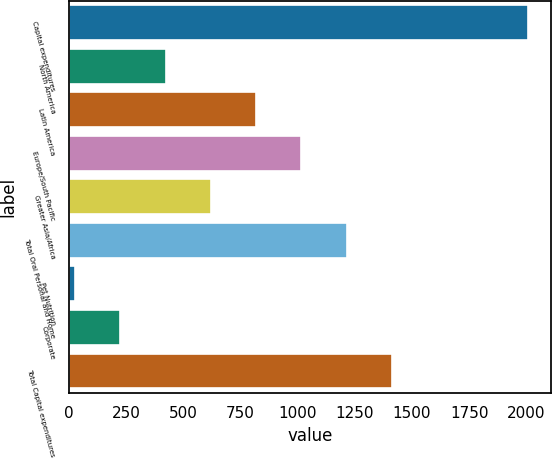Convert chart to OTSL. <chart><loc_0><loc_0><loc_500><loc_500><bar_chart><fcel>Capital expenditures<fcel>North America<fcel>Latin America<fcel>Europe/South Pacific<fcel>Greater Asia/Africa<fcel>Total Oral Personal and Home<fcel>Pet Nutrition<fcel>Corporate<fcel>Total Capital expenditures<nl><fcel>2006<fcel>422.64<fcel>818.48<fcel>1016.4<fcel>620.56<fcel>1214.32<fcel>26.8<fcel>224.72<fcel>1412.24<nl></chart> 